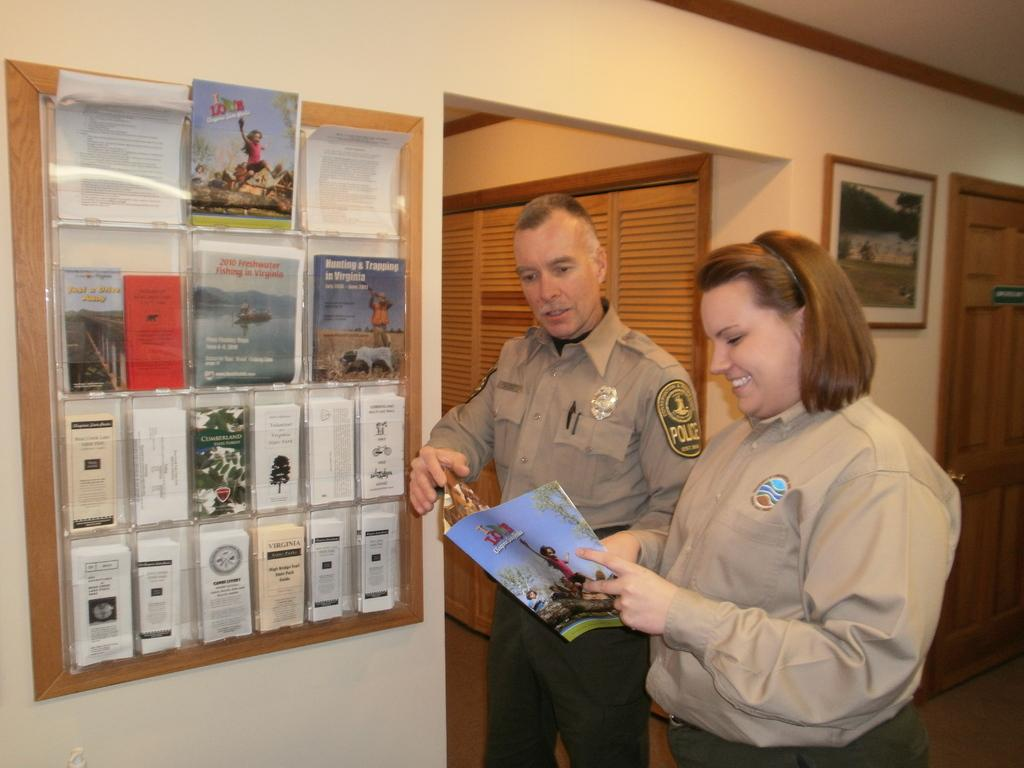How many people are present in the image? There are 2 people standing in the image. What are the people holding in the image? The people are holding a book. What other items can be seen in the image related to reading or studying? There are photo frames, books, papers, and 2 doors in the image. How far can the snakes stretch in the image? There are no snakes present in the image, so it is not possible to determine how far they might stretch. 